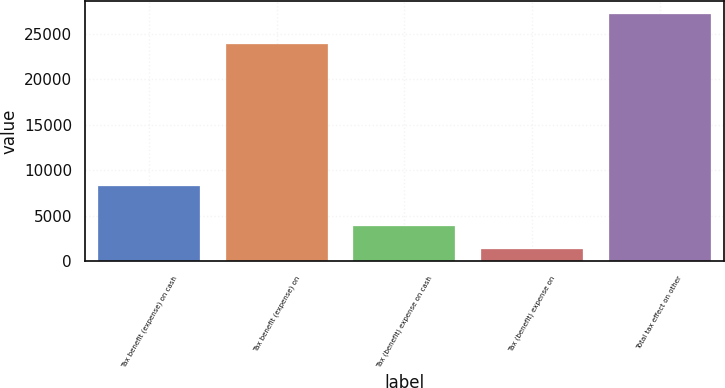Convert chart. <chart><loc_0><loc_0><loc_500><loc_500><bar_chart><fcel>Tax benefit (expense) on cash<fcel>Tax benefit (expense) on<fcel>Tax (benefit) expense on cash<fcel>Tax (benefit) expense on<fcel>Total tax effect on other<nl><fcel>8259<fcel>23869<fcel>3917.9<fcel>1327<fcel>27236<nl></chart> 